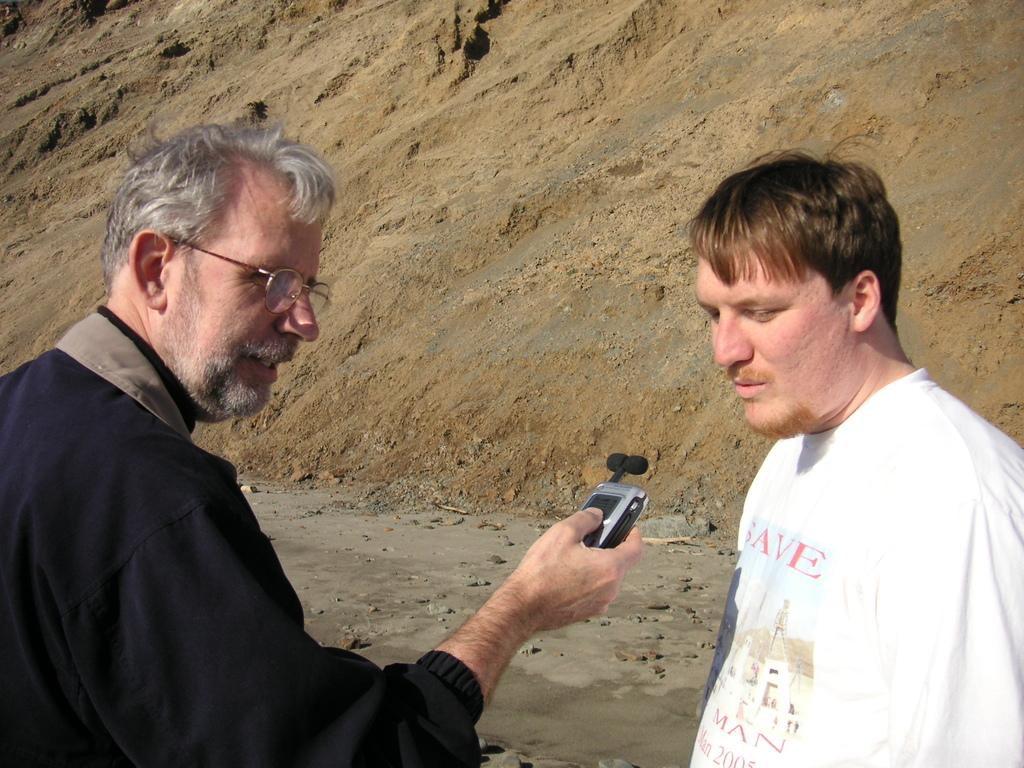What are the men in the image doing? The men in the image are standing on the ground. Can you describe what one of the men is holding? One of the men is holding a machine in his hands. What can be seen in the background of the image? There is a heap of sand in the background of the image. What type of soap is being used to clean the boat in the image? There is no boat or soap present in the image. How many nails can be seen in the image? There are no nails visible in the image. 